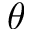Convert formula to latex. <formula><loc_0><loc_0><loc_500><loc_500>\theta</formula> 